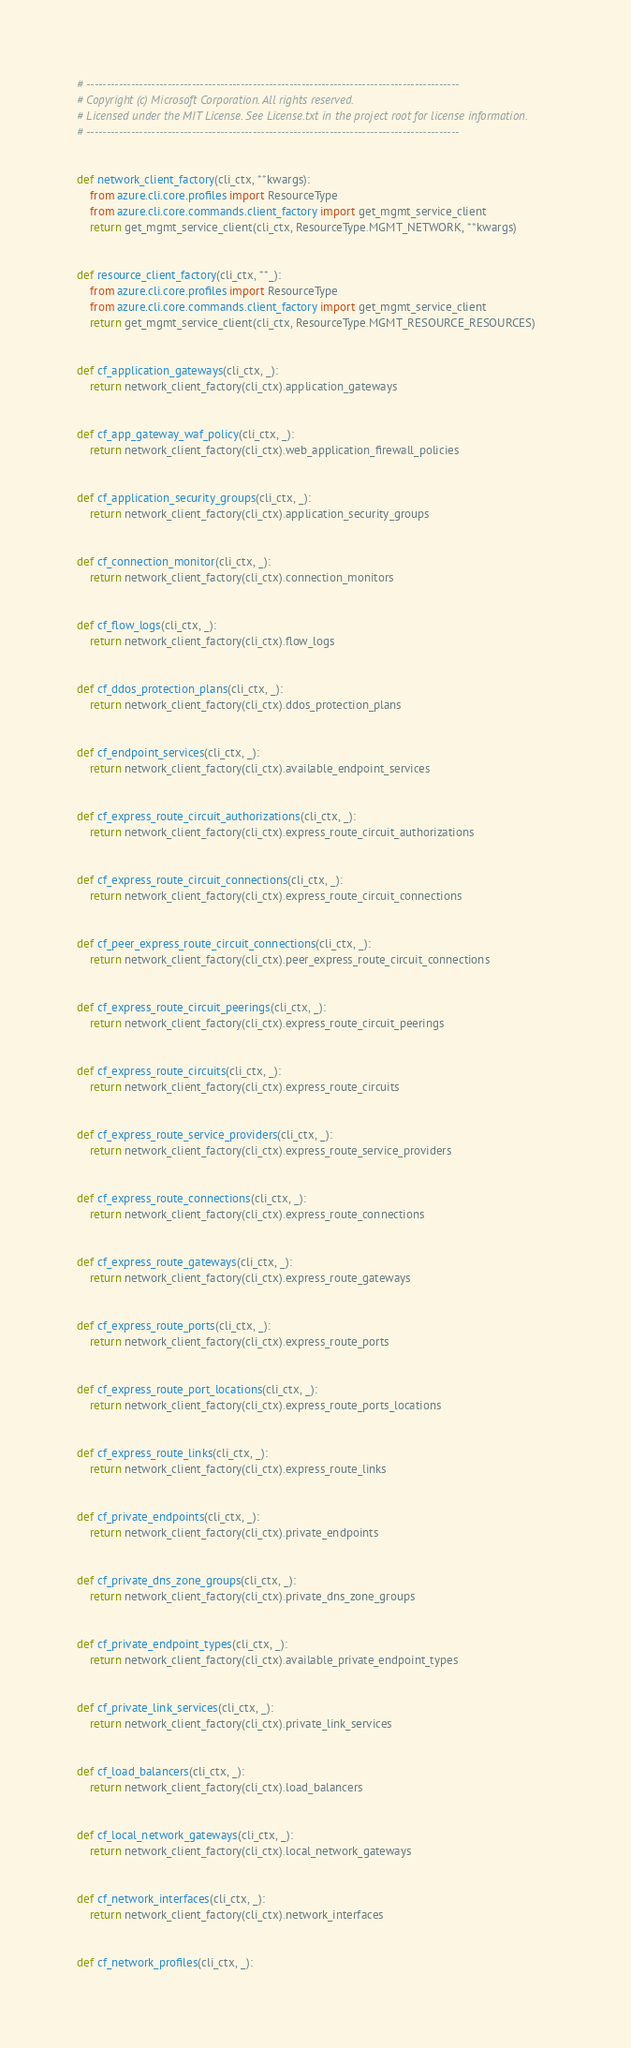Convert code to text. <code><loc_0><loc_0><loc_500><loc_500><_Python_># --------------------------------------------------------------------------------------------
# Copyright (c) Microsoft Corporation. All rights reserved.
# Licensed under the MIT License. See License.txt in the project root for license information.
# --------------------------------------------------------------------------------------------


def network_client_factory(cli_ctx, **kwargs):
    from azure.cli.core.profiles import ResourceType
    from azure.cli.core.commands.client_factory import get_mgmt_service_client
    return get_mgmt_service_client(cli_ctx, ResourceType.MGMT_NETWORK, **kwargs)


def resource_client_factory(cli_ctx, **_):
    from azure.cli.core.profiles import ResourceType
    from azure.cli.core.commands.client_factory import get_mgmt_service_client
    return get_mgmt_service_client(cli_ctx, ResourceType.MGMT_RESOURCE_RESOURCES)


def cf_application_gateways(cli_ctx, _):
    return network_client_factory(cli_ctx).application_gateways


def cf_app_gateway_waf_policy(cli_ctx, _):
    return network_client_factory(cli_ctx).web_application_firewall_policies


def cf_application_security_groups(cli_ctx, _):
    return network_client_factory(cli_ctx).application_security_groups


def cf_connection_monitor(cli_ctx, _):
    return network_client_factory(cli_ctx).connection_monitors


def cf_flow_logs(cli_ctx, _):
    return network_client_factory(cli_ctx).flow_logs


def cf_ddos_protection_plans(cli_ctx, _):
    return network_client_factory(cli_ctx).ddos_protection_plans


def cf_endpoint_services(cli_ctx, _):
    return network_client_factory(cli_ctx).available_endpoint_services


def cf_express_route_circuit_authorizations(cli_ctx, _):
    return network_client_factory(cli_ctx).express_route_circuit_authorizations


def cf_express_route_circuit_connections(cli_ctx, _):
    return network_client_factory(cli_ctx).express_route_circuit_connections


def cf_peer_express_route_circuit_connections(cli_ctx, _):
    return network_client_factory(cli_ctx).peer_express_route_circuit_connections


def cf_express_route_circuit_peerings(cli_ctx, _):
    return network_client_factory(cli_ctx).express_route_circuit_peerings


def cf_express_route_circuits(cli_ctx, _):
    return network_client_factory(cli_ctx).express_route_circuits


def cf_express_route_service_providers(cli_ctx, _):
    return network_client_factory(cli_ctx).express_route_service_providers


def cf_express_route_connections(cli_ctx, _):
    return network_client_factory(cli_ctx).express_route_connections


def cf_express_route_gateways(cli_ctx, _):
    return network_client_factory(cli_ctx).express_route_gateways


def cf_express_route_ports(cli_ctx, _):
    return network_client_factory(cli_ctx).express_route_ports


def cf_express_route_port_locations(cli_ctx, _):
    return network_client_factory(cli_ctx).express_route_ports_locations


def cf_express_route_links(cli_ctx, _):
    return network_client_factory(cli_ctx).express_route_links


def cf_private_endpoints(cli_ctx, _):
    return network_client_factory(cli_ctx).private_endpoints


def cf_private_dns_zone_groups(cli_ctx, _):
    return network_client_factory(cli_ctx).private_dns_zone_groups


def cf_private_endpoint_types(cli_ctx, _):
    return network_client_factory(cli_ctx).available_private_endpoint_types


def cf_private_link_services(cli_ctx, _):
    return network_client_factory(cli_ctx).private_link_services


def cf_load_balancers(cli_ctx, _):
    return network_client_factory(cli_ctx).load_balancers


def cf_local_network_gateways(cli_ctx, _):
    return network_client_factory(cli_ctx).local_network_gateways


def cf_network_interfaces(cli_ctx, _):
    return network_client_factory(cli_ctx).network_interfaces


def cf_network_profiles(cli_ctx, _):</code> 